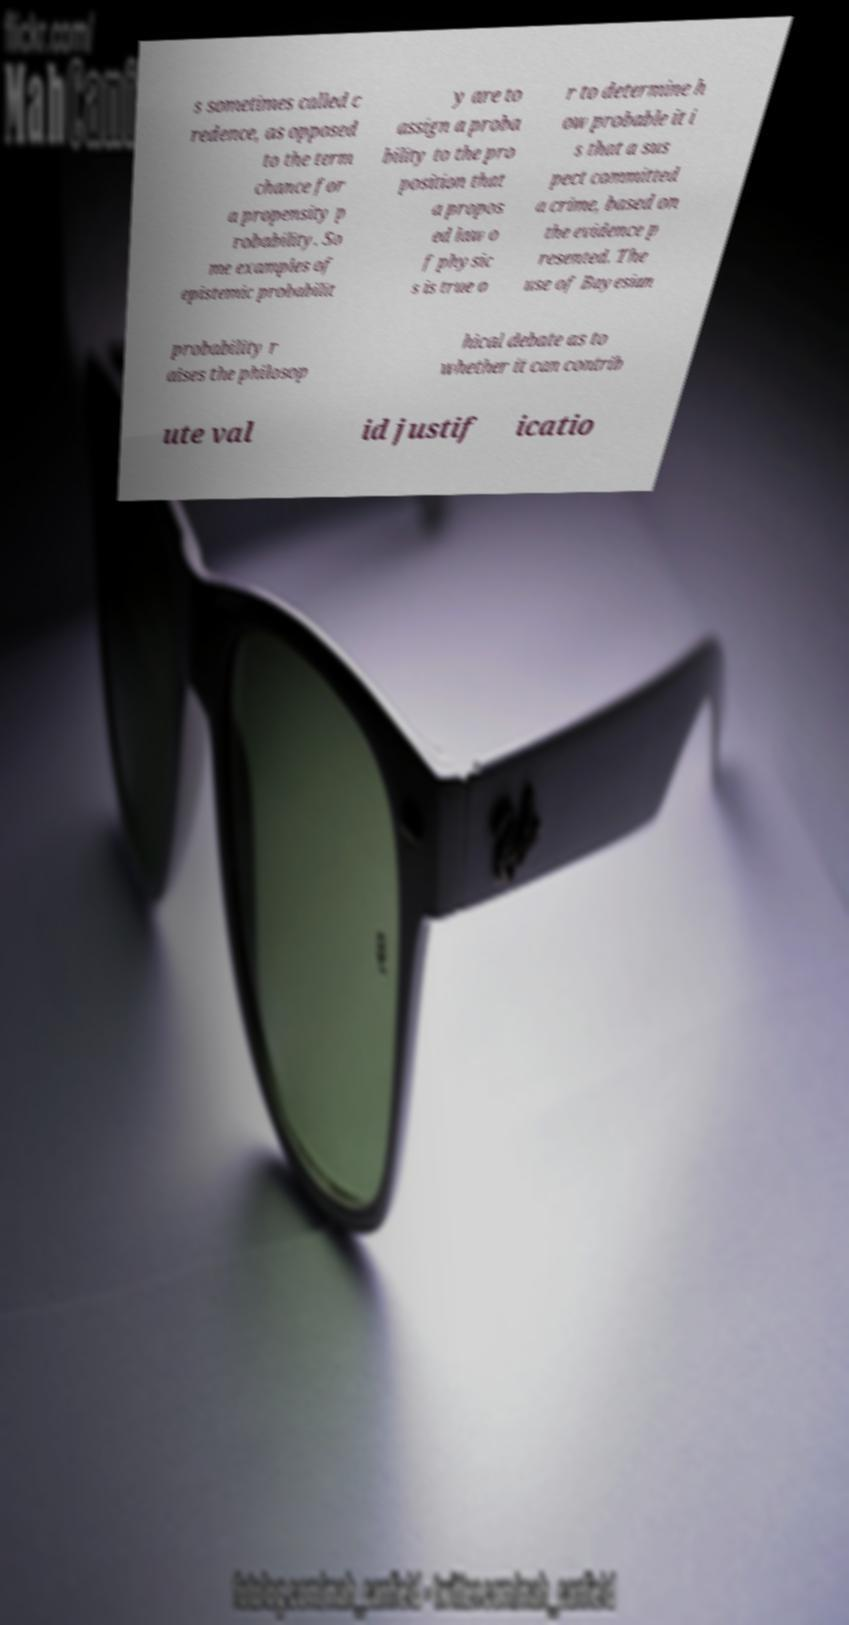There's text embedded in this image that I need extracted. Can you transcribe it verbatim? s sometimes called c redence, as opposed to the term chance for a propensity p robability. So me examples of epistemic probabilit y are to assign a proba bility to the pro position that a propos ed law o f physic s is true o r to determine h ow probable it i s that a sus pect committed a crime, based on the evidence p resented. The use of Bayesian probability r aises the philosop hical debate as to whether it can contrib ute val id justif icatio 